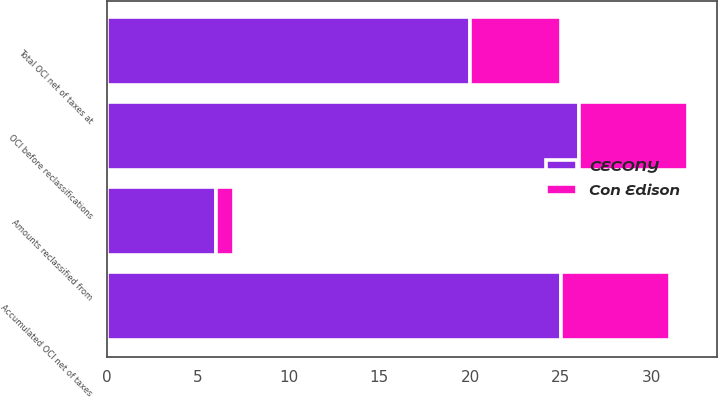Convert chart to OTSL. <chart><loc_0><loc_0><loc_500><loc_500><stacked_bar_chart><ecel><fcel>Accumulated OCI net of taxes<fcel>OCI before reclassifications<fcel>Amounts reclassified from<fcel>Total OCI net of taxes at<nl><fcel>CECONY<fcel>25<fcel>26<fcel>6<fcel>20<nl><fcel>Con Edison<fcel>6<fcel>6<fcel>1<fcel>5<nl></chart> 